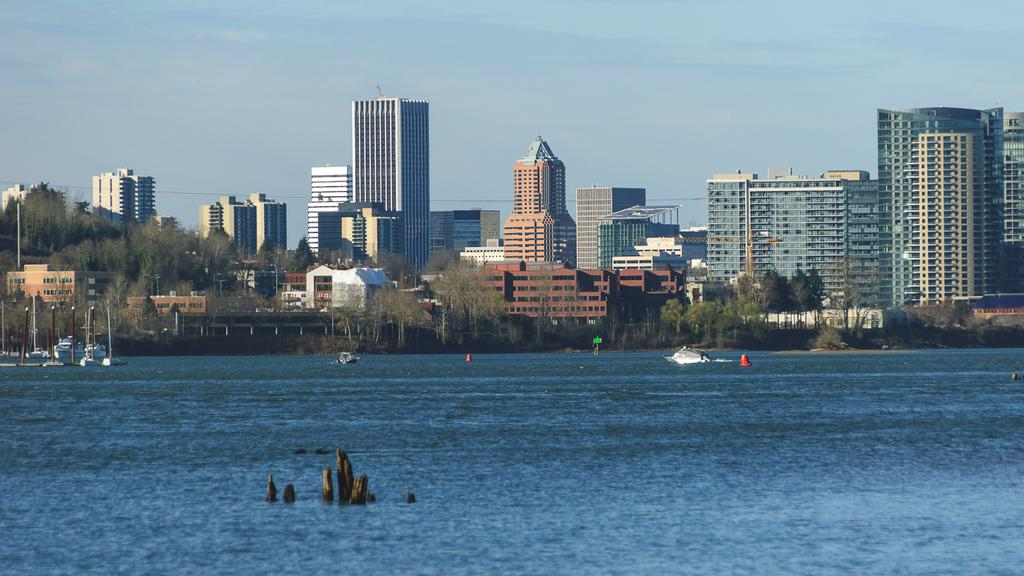What is present at the bottom side of the image? There is water at the bottom side of the image. What can be seen in the background of the image? There are buildings and trees in the background of the image. What is visible at the top side of the image? The sky is visible at the top side of the image. Can you see a shop in the image? There is no shop present in the image. What part of the body is visible in the image? There are no body parts visible in the image. 